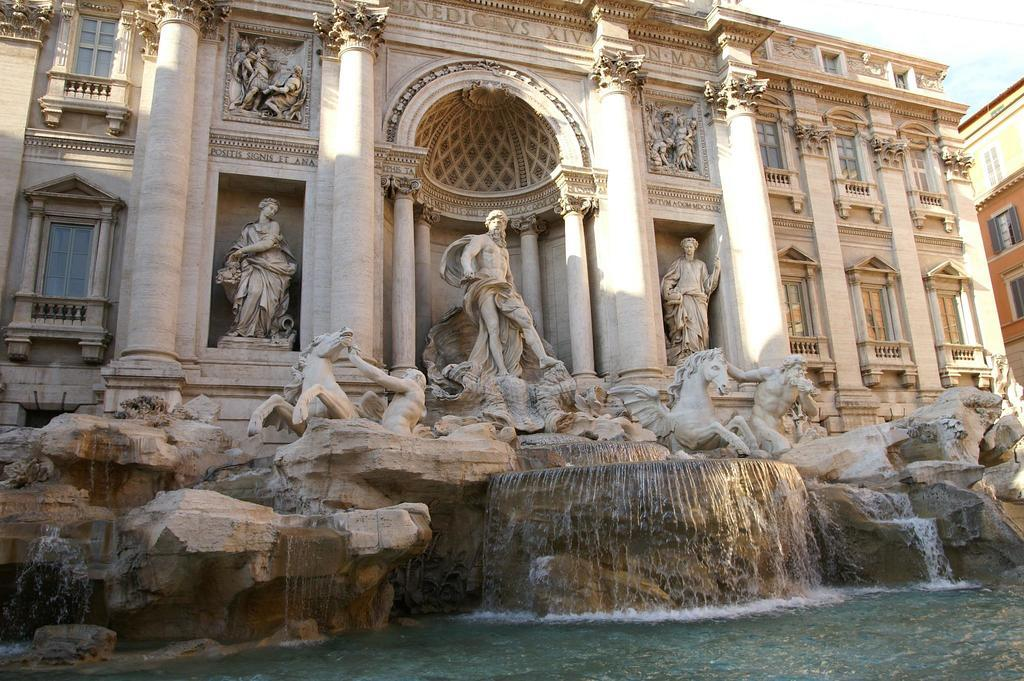What is the main subject of the image? The main subject of the image is the "Trevi Fountain". What can be seen on the right side of the fountain? There is a building on the right side of the fountain. What is visible behind the building? The sky is visible behind the building. Can you see a goose wearing a vest in the image? No, there is no goose or vest present in the image. Are there any visible teeth in the image? No, there are no visible teeth in the image. 